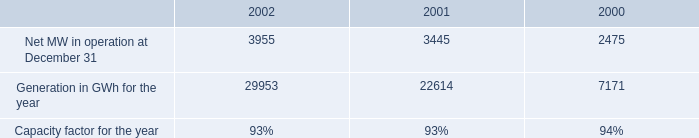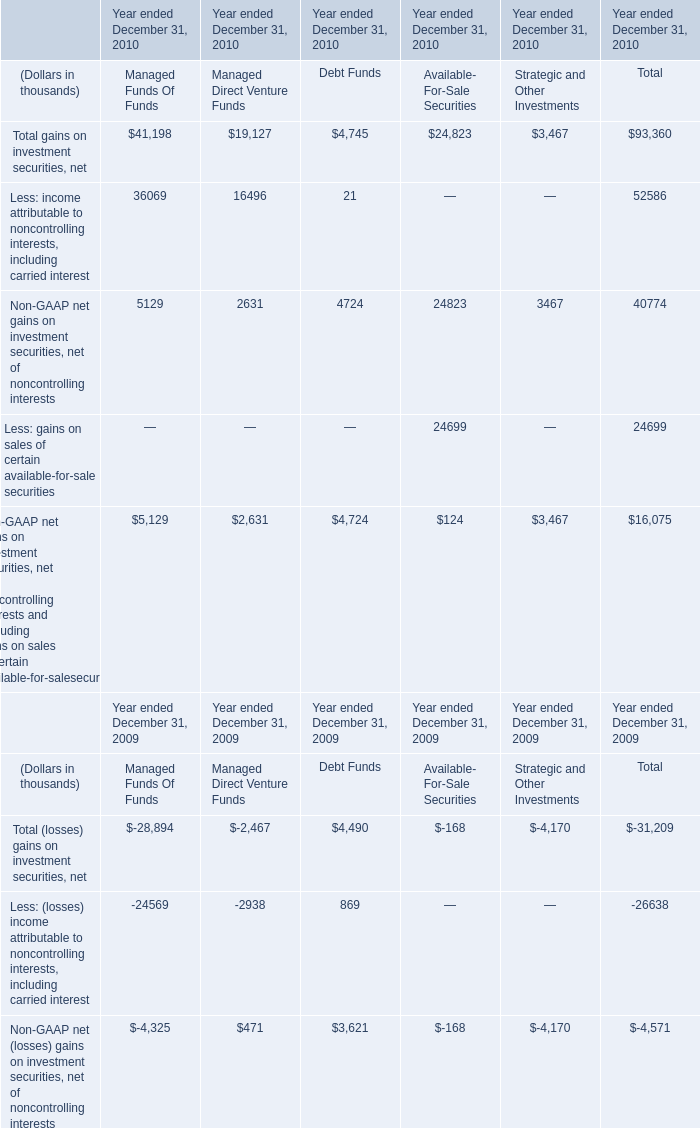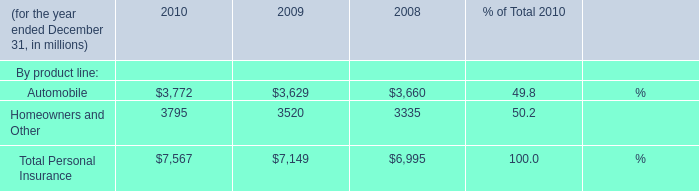Which section is Total gains on investment securities, net the most? 
Answer: Managed Funds Of Funds. 